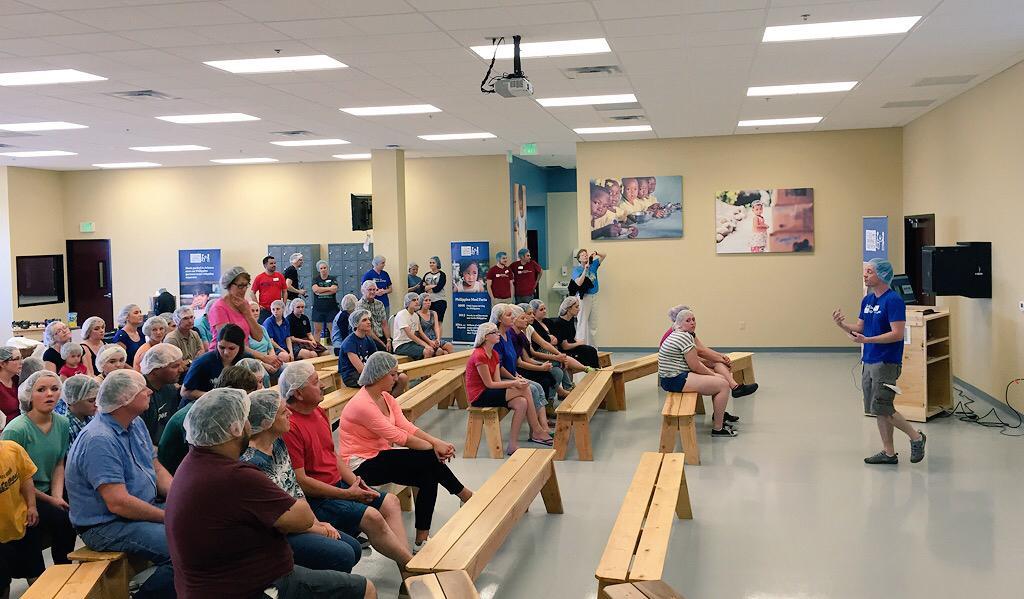How would you summarize this image in a sentence or two? There are few people sitting on the chair and few are standing and listening to the the person talking in the middle. In this room we can see door,posters on the wall,hoarding,projector and a table. 